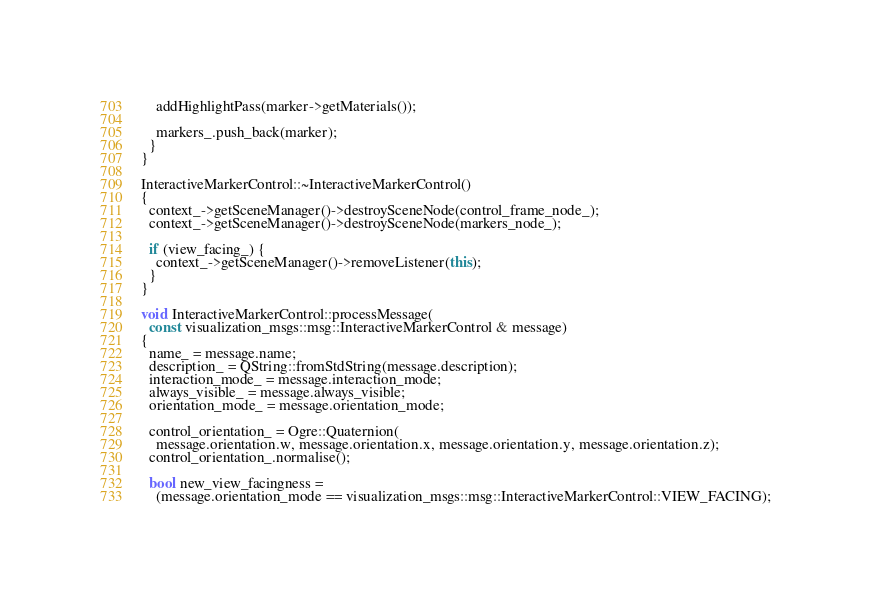Convert code to text. <code><loc_0><loc_0><loc_500><loc_500><_C++_>    addHighlightPass(marker->getMaterials());

    markers_.push_back(marker);
  }
}

InteractiveMarkerControl::~InteractiveMarkerControl()
{
  context_->getSceneManager()->destroySceneNode(control_frame_node_);
  context_->getSceneManager()->destroySceneNode(markers_node_);

  if (view_facing_) {
    context_->getSceneManager()->removeListener(this);
  }
}

void InteractiveMarkerControl::processMessage(
  const visualization_msgs::msg::InteractiveMarkerControl & message)
{
  name_ = message.name;
  description_ = QString::fromStdString(message.description);
  interaction_mode_ = message.interaction_mode;
  always_visible_ = message.always_visible;
  orientation_mode_ = message.orientation_mode;

  control_orientation_ = Ogre::Quaternion(
    message.orientation.w, message.orientation.x, message.orientation.y, message.orientation.z);
  control_orientation_.normalise();

  bool new_view_facingness =
    (message.orientation_mode == visualization_msgs::msg::InteractiveMarkerControl::VIEW_FACING);</code> 